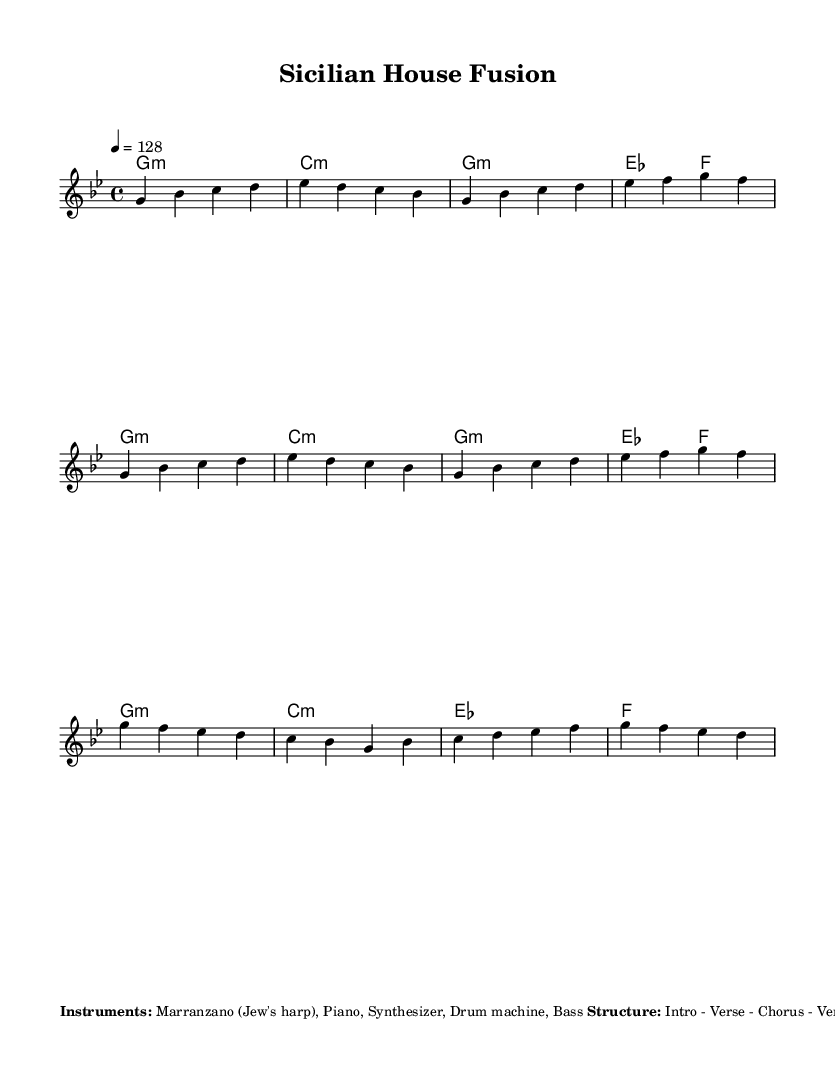What is the key signature of this music? The key signature is G minor, which has two flats (B flat and E flat). This is determined by looking at the clef and the key indicated at the beginning of the staff.
Answer: G minor What is the time signature of this music? The time signature is 4/4, which means there are four beats in each measure and the quarter note gets one beat. This is indicated directly next to the clef at the beginning of the score.
Answer: 4/4 What is the tempo marking of this piece? The tempo marking is 128 beats per minute, indicated by the number 4 = 128 above the staff. This tells performers the speed at which to play.
Answer: 128 How many measures are in the chorus section? The chorus is four measures long, indicated by the repeated structure after the verse and the rhythmic content shown in the music section labeled as Chorus.
Answer: 4 What instruments are featured in this composition? The instruments include Marranzano (Jew's harp), Piano, Synthesizer, Drum machine, and Bass, as listed in the additional notes at the bottom of the score.
Answer: Marranzano, Piano, Synthesizer, Drum machine, Bass Which traditional instrument is used for rhythmic plucking? The Marranzano (Jew's harp) is used for rhythmic plucking in this piece, as noted in the additional information regarding instrumentation and performance techniques.
Answer: Marranzano What type of bass line is indicated in the score? The bass line primarily consists of root notes following the harmony with some walking bass lines, as described in the additional notes. This provides grounding for the harmonic structure.
Answer: Root notes and walking bass lines 